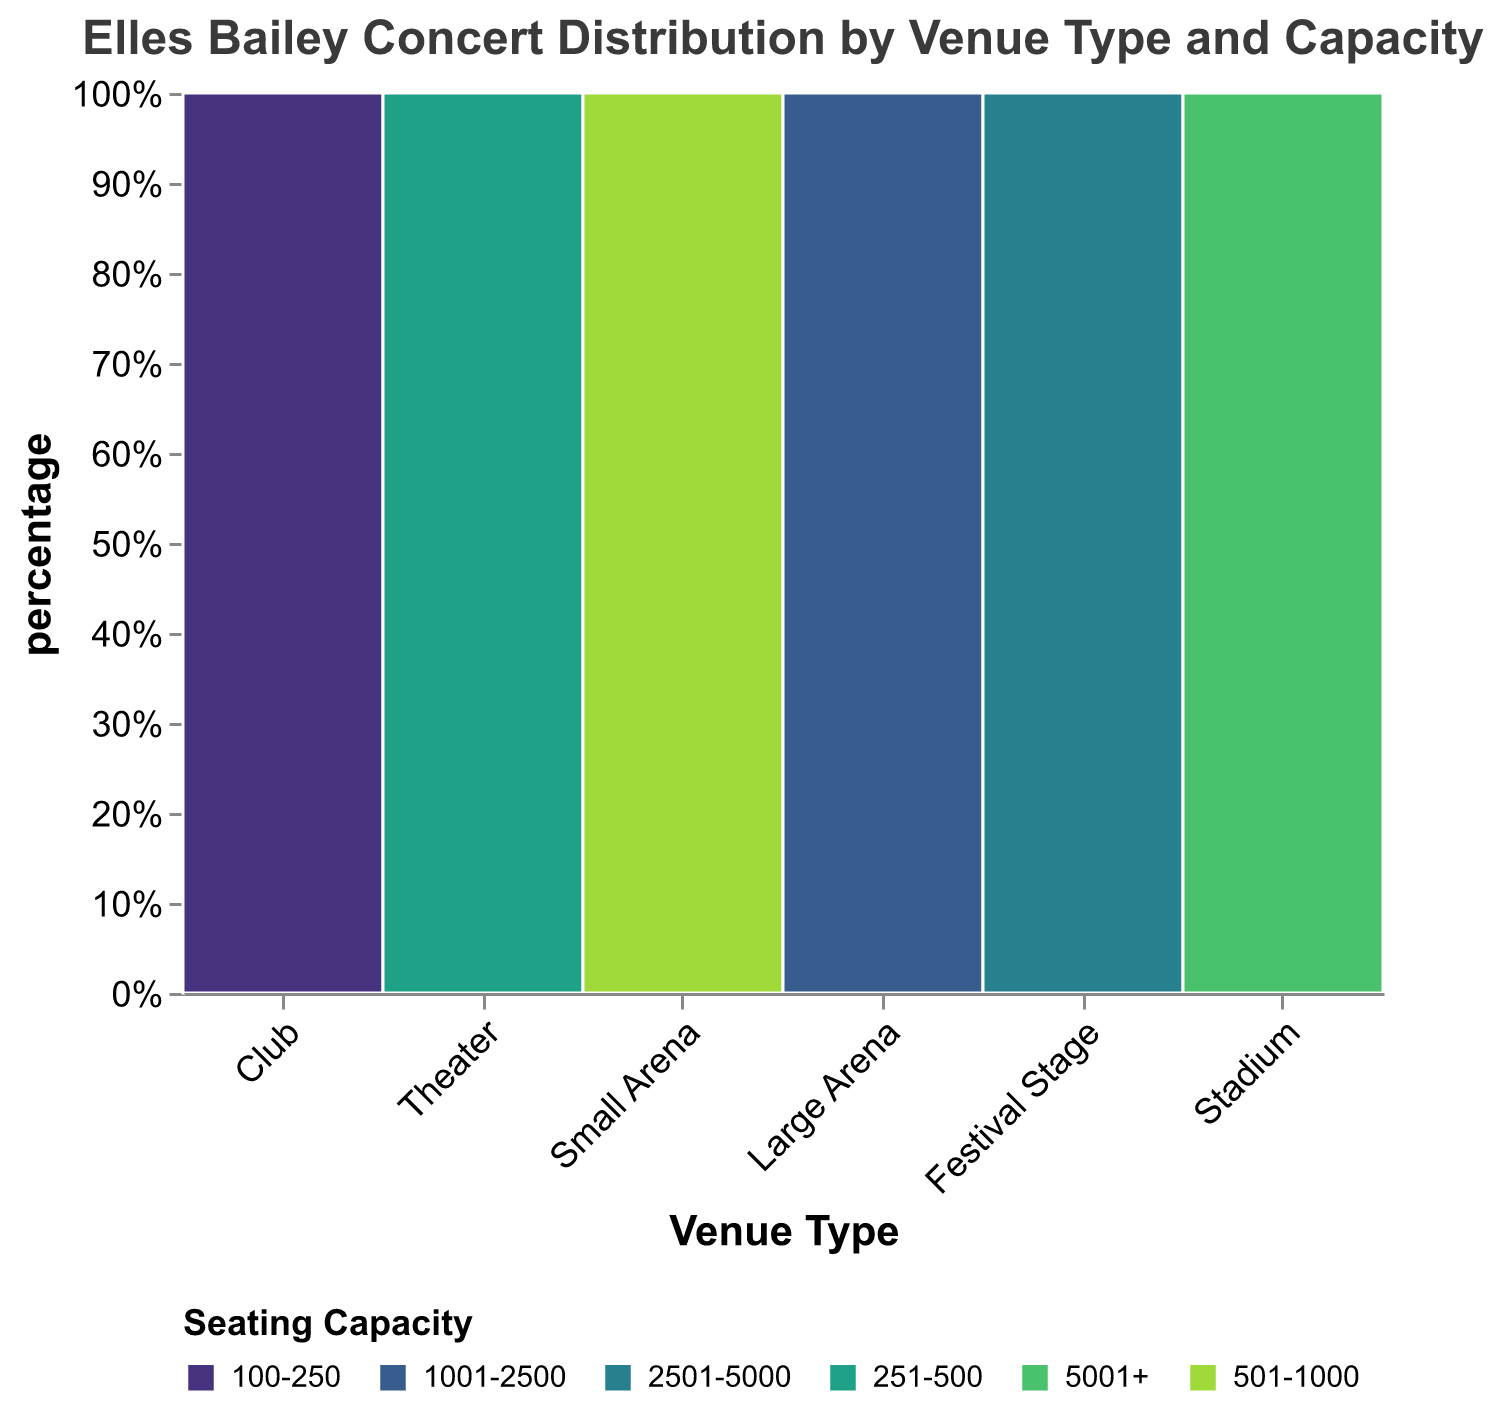What is the title of the mosaic plot? The title is at the top center of the plot and is clearly stated. It reads "Elles Bailey Concert Distribution by Venue Type and Capacity."
Answer: Elles Bailey Concert Distribution by Venue Type and Capacity Which venue type has the most concerts with a seating capacity of 100-250? The plot shows different colors representing different seating capacities. By observing the plot, the "Club" venue type has the largest section in the 100-250 seating capacity.
Answer: Club How many concerts were held in theaters and what is their seating capacity range? By looking at the "Theater" bar, we can see the section labeled with the seating capacity range "251-500." The plot also shows the number of concerts for this category.
Answer: 251-500 What percentage of concerts were held at small arenas with a seating capacity of 501-1000? Hovering over or observing the tooltip for the section labeled "Small Arena" and "501-1000" reveals the percentage value.
Answer: Approximately 25% Compare the number of concerts held in large arenas versus stadiums. Which has more? The "Large Arena" section shows several more concerts compared to the single concert in the "Stadium" section.
Answer: Large arenas have more Out of all venue types, which one has the least number of concerts and what is the seating capacity? The plot visualizes "Stadium" as the venue type with the smallest section. It has the seating capacity of "5001+."
Answer: Stadium, 5001+ How does the distribution of concerts in clubs compare to those in theaters by seating capacity? Observing the plot, clubs mostly fall into the 100-250 category, whereas theaters are in the 251-500 range. Clubs have a larger section than theaters.
Answer: More concerts in clubs, Seating Capacity: 100-250 vs 251-500 Calculate the total number of concerts held in venues with seating capacities of 1001-2500 and 2501-5000. Sum the numbers of concerts for "Large Arena" (3 concerts) and "Festival Stage" (2 concerts).
Answer: 3 + 2 = 5 Which venue type has a more balanced distribution of concerts across different seating capacities? By examining the sections within each venue type, theaters (251-500) seem to be balanced but only within their seating capacity range. Most others are skewed.
Answer: Theaters What is the proportion of concerts held in festival stages versus clubs? Compare the sections corresponding to "Festival Stage" and "Club." Clubs have a higher number of concerts, so their proportion is larger.
Answer: Lower proportion in festival stages 